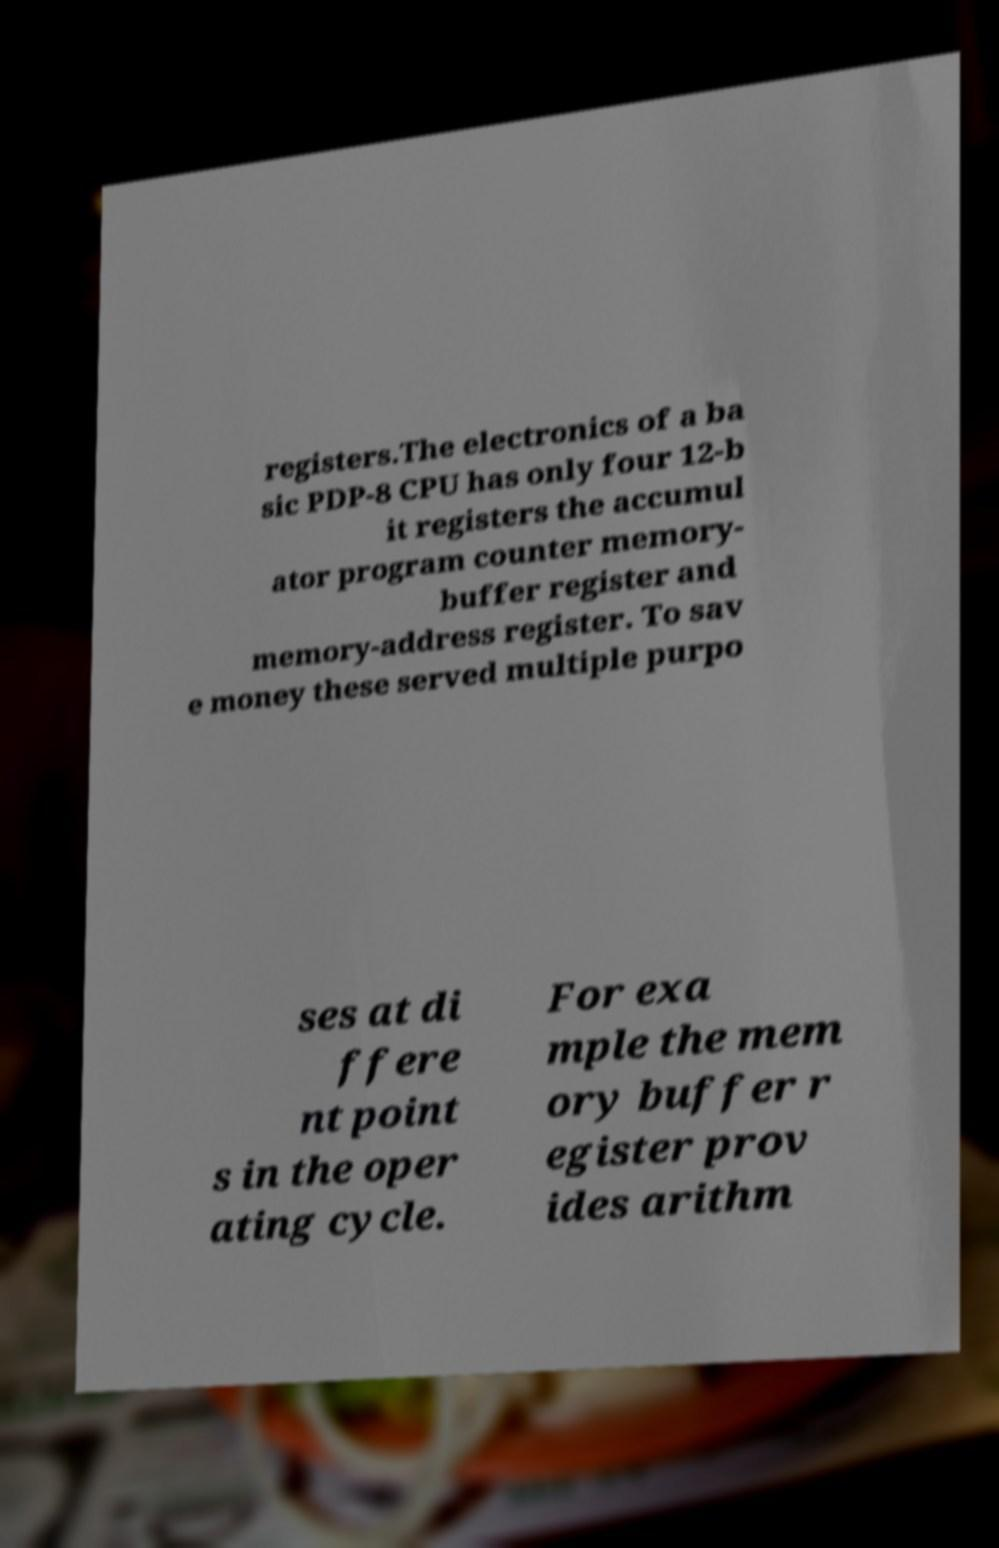Can you accurately transcribe the text from the provided image for me? registers.The electronics of a ba sic PDP-8 CPU has only four 12-b it registers the accumul ator program counter memory- buffer register and memory-address register. To sav e money these served multiple purpo ses at di ffere nt point s in the oper ating cycle. For exa mple the mem ory buffer r egister prov ides arithm 